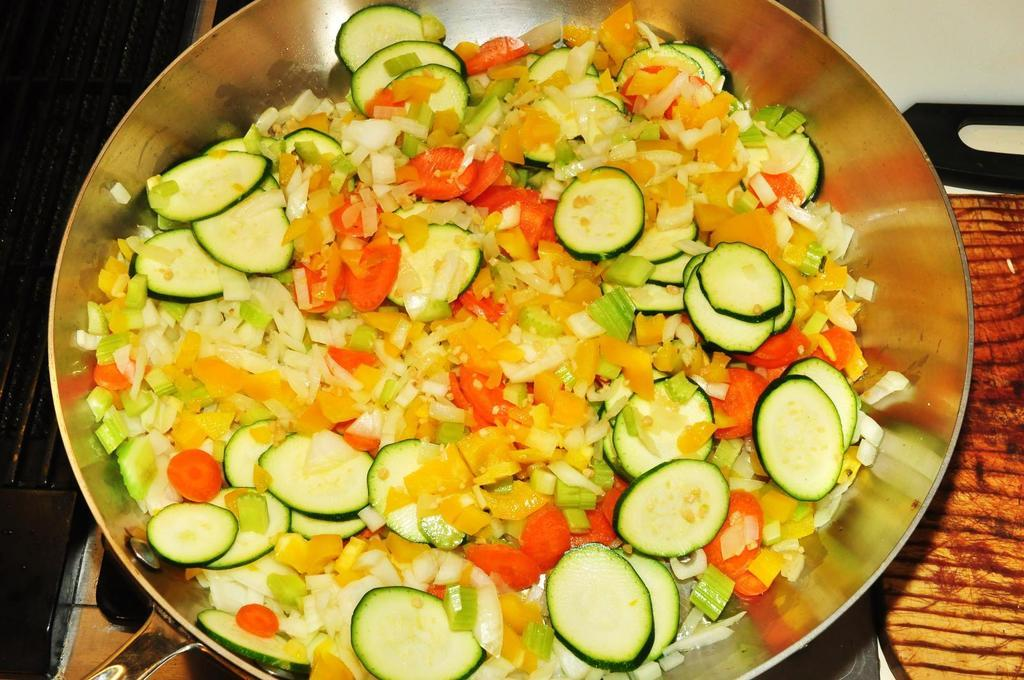What is in the bowl that is visible in the image? There are vegetable slices in a bowl in the image. What other item can be seen in the image? There is a chopping board in the image. Where is the seashore located in the image? There is no seashore present in the image. What type of notebook is visible on the chopping board? There is no notebook present in the image. 